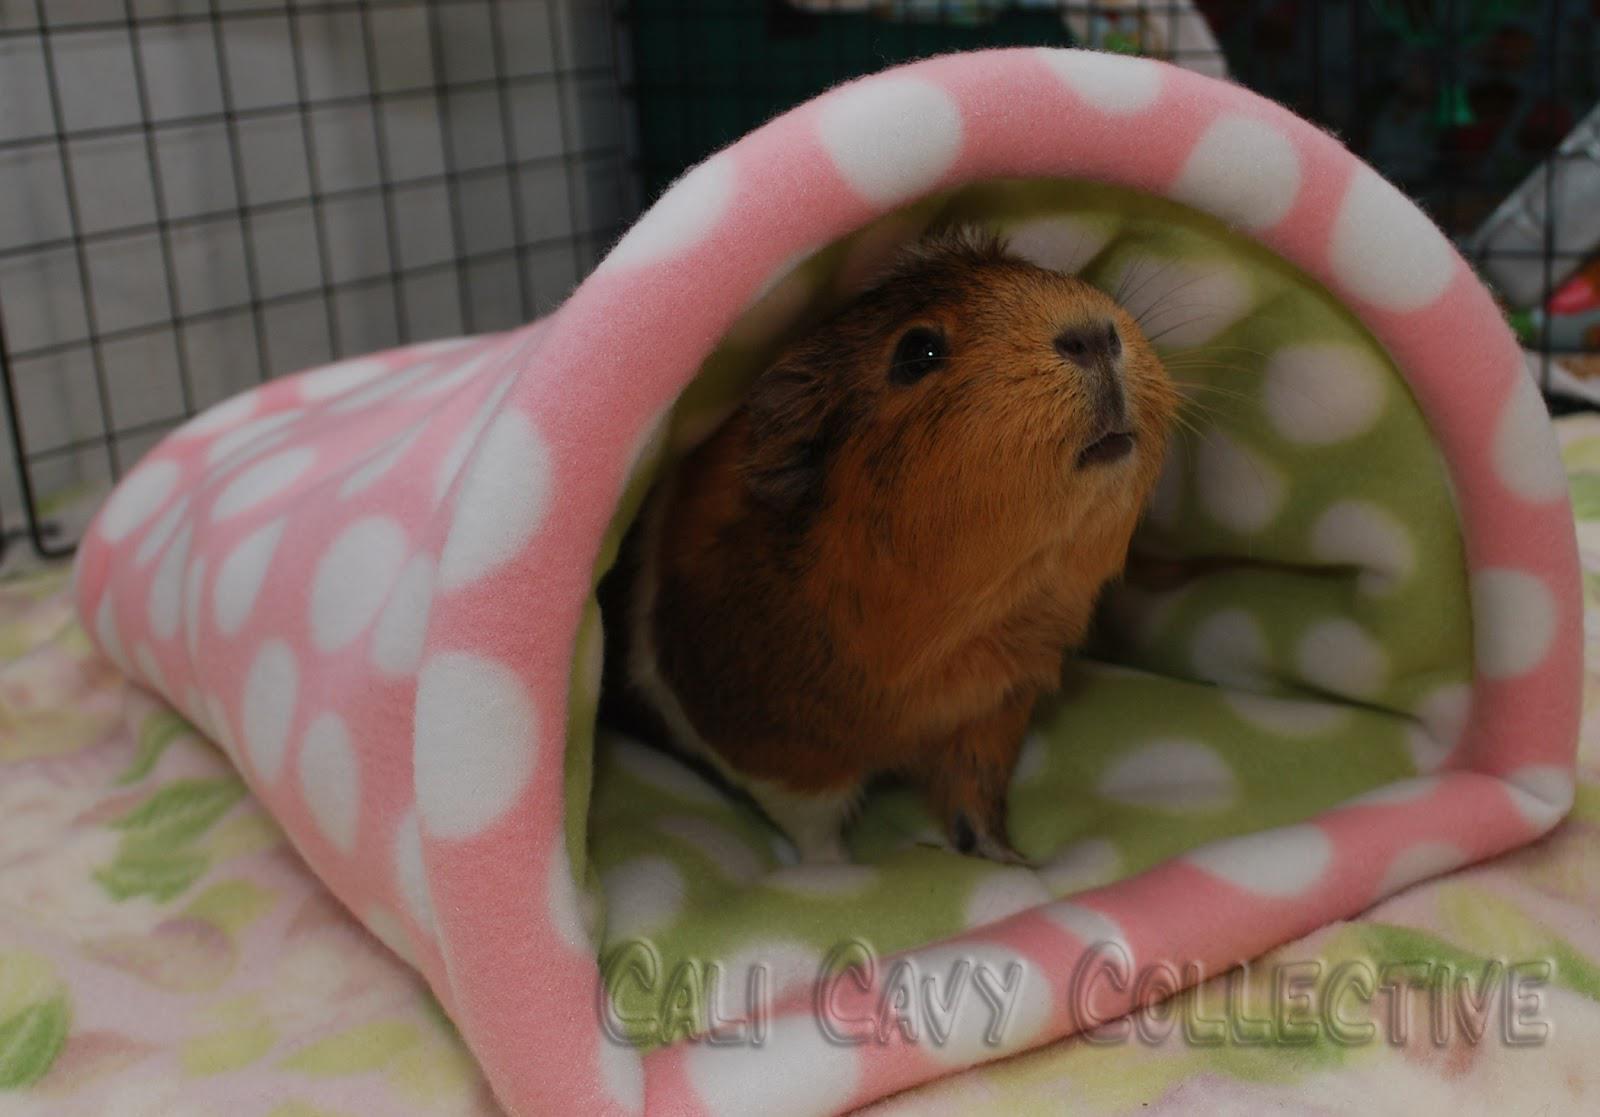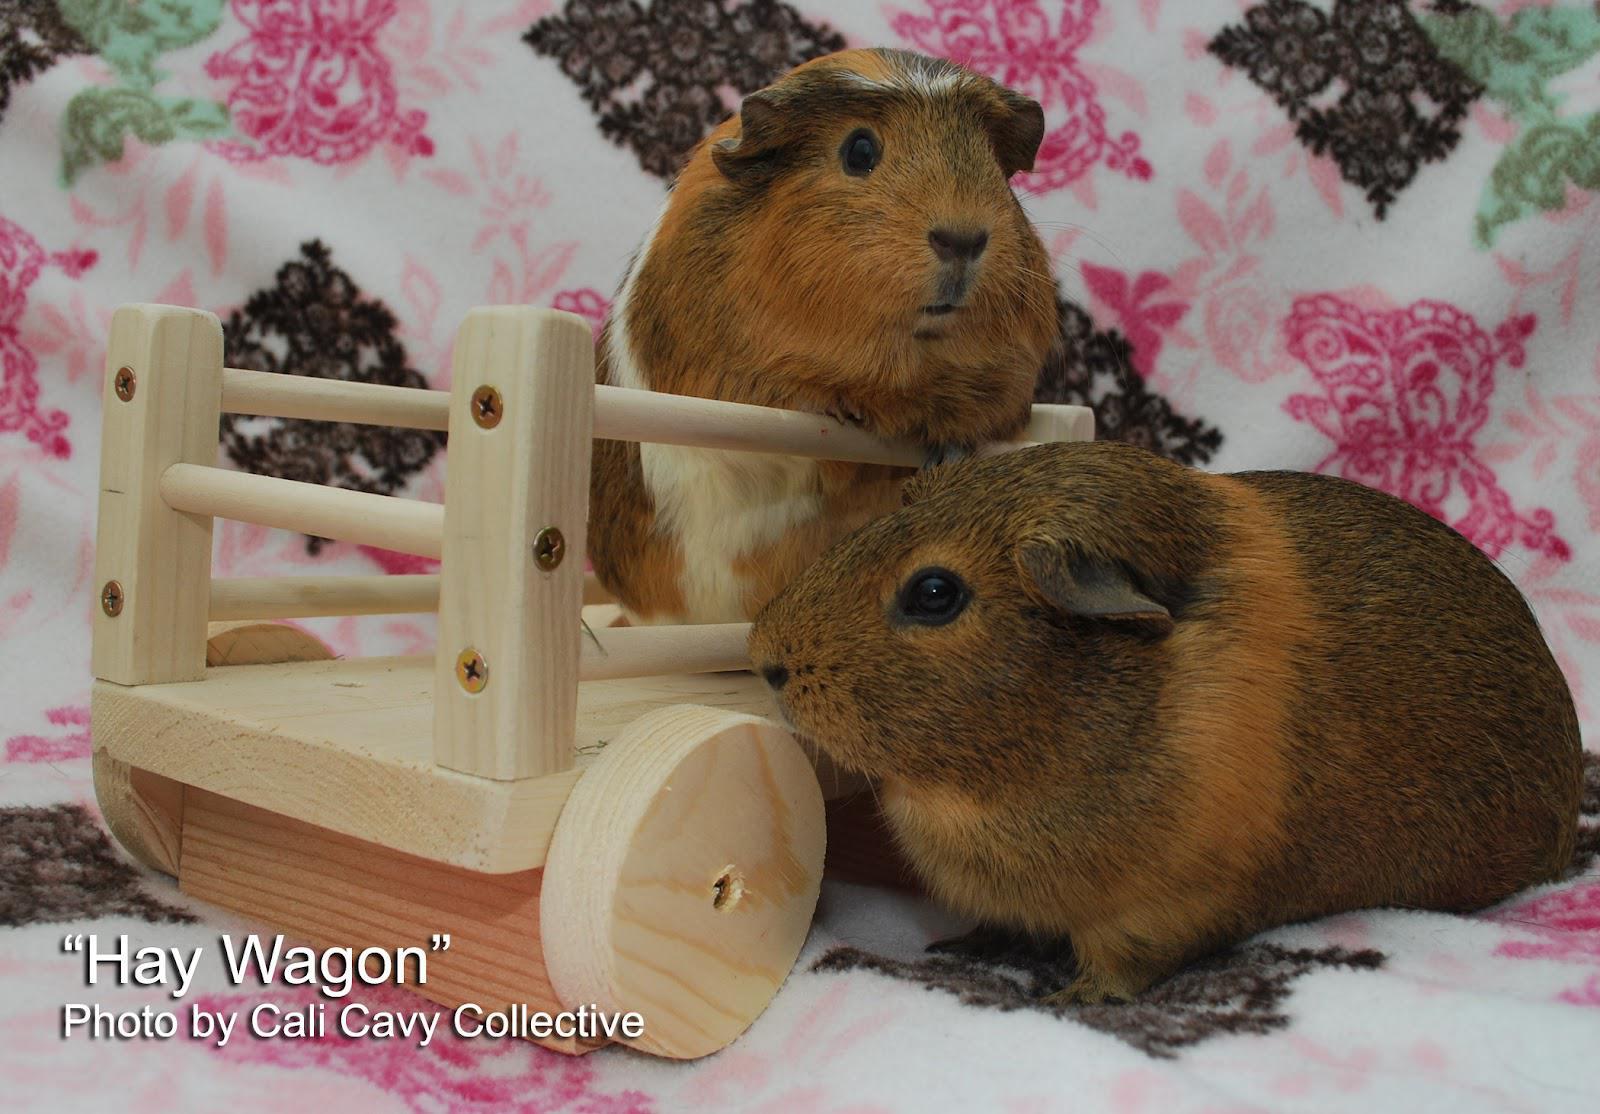The first image is the image on the left, the second image is the image on the right. Given the left and right images, does the statement "One image shows a single hamster under a semi-circular arch, and the other image includes a hamster in a wheeled wooden wagon." hold true? Answer yes or no. Yes. The first image is the image on the left, the second image is the image on the right. Examine the images to the left and right. Is the description "At least one image has a backdrop using a white blanket with pink and black designs on it." accurate? Answer yes or no. Yes. 